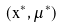Convert formula to latex. <formula><loc_0><loc_0><loc_500><loc_500>( x ^ { \ast } , \mu ^ { \ast } )</formula> 